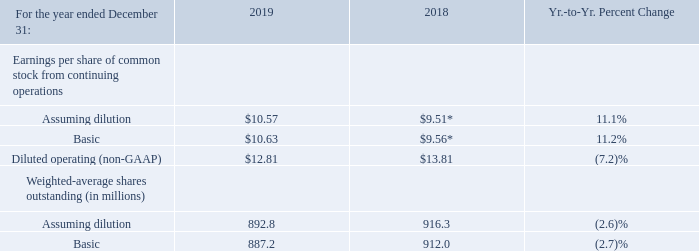Basic earnings per share is computed on the basis of the weighted-average number of shares of common stock outstanding during the period. Diluted earnings per share is computed on the basis of the weighted-average number of shares of common stock outstanding plus the effect of dilutive potential common shares outstanding during the period using the treasury stock method. Dilutive potential common shares include outstanding stock options and stock awards.
* Includes a charge of $2.0 billion or $2.23 of basic and diluted earnings per share in 2018 associated with U.S. tax reform.
Actual shares outstanding at December 31, 2019 and 2018 were 887.1 million and 892.5 million, respectively. The year-to- year decrease was primarily the result of the common stock repurchase program. The average number of common shares
outstanding assuming dilution was 23.5 million shares lower in 2019 versus 2018
What caused the decrease in the actual shares? The year-to- year decrease was primarily the result of the common stock repurchase program. What was the increase / (decrease) in the average number of common shares in 2019? 23.5 million shares lower in 2019 versus 2018. What additional charges were included in 2018? Includes a charge of $2.0 billion or $2.23 of basic and diluted earnings per share in 2018 associated with u.s. tax reform. What was the increase / (decrease) from the Earnings per share of common stock from continuing operations basic? 10.63 - 9.56
Answer: 1.07. What is the increase / (decrease) from the Earnings per share of common stock from continuing operations Diluted operating (non-GAAP)? 12.81 - 13.81
Answer: -1. What is the increase / (decrease) in the Weighted-average shares outstanding assuming dilution? 892.8 - 916.3
Answer: -23.5. 